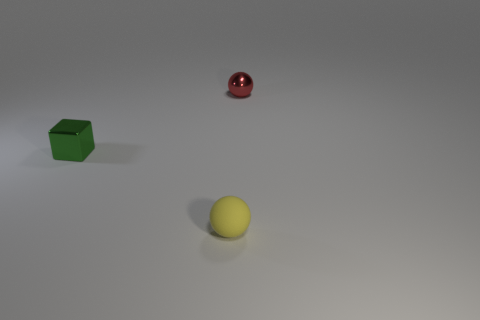Is there any other thing that is the same shape as the rubber thing?
Your answer should be compact. Yes. Do the tiny object in front of the green cube and the tiny metallic thing behind the green block have the same shape?
Your answer should be very brief. Yes. Are there any other green metallic things of the same size as the green thing?
Make the answer very short. No. There is a object that is to the right of the yellow matte sphere; what material is it?
Your answer should be very brief. Metal. Is the material of the ball on the left side of the red metallic object the same as the tiny cube?
Provide a short and direct response. No. Are any tiny red spheres visible?
Your answer should be compact. Yes. What color is the sphere that is made of the same material as the green object?
Ensure brevity in your answer.  Red. There is a ball that is in front of the tiny metallic object in front of the thing on the right side of the yellow ball; what color is it?
Provide a short and direct response. Yellow. What number of things are tiny objects that are in front of the small red shiny ball or balls that are to the left of the red ball?
Make the answer very short. 2. What is the shape of the green thing that is the same size as the rubber sphere?
Your response must be concise. Cube. 